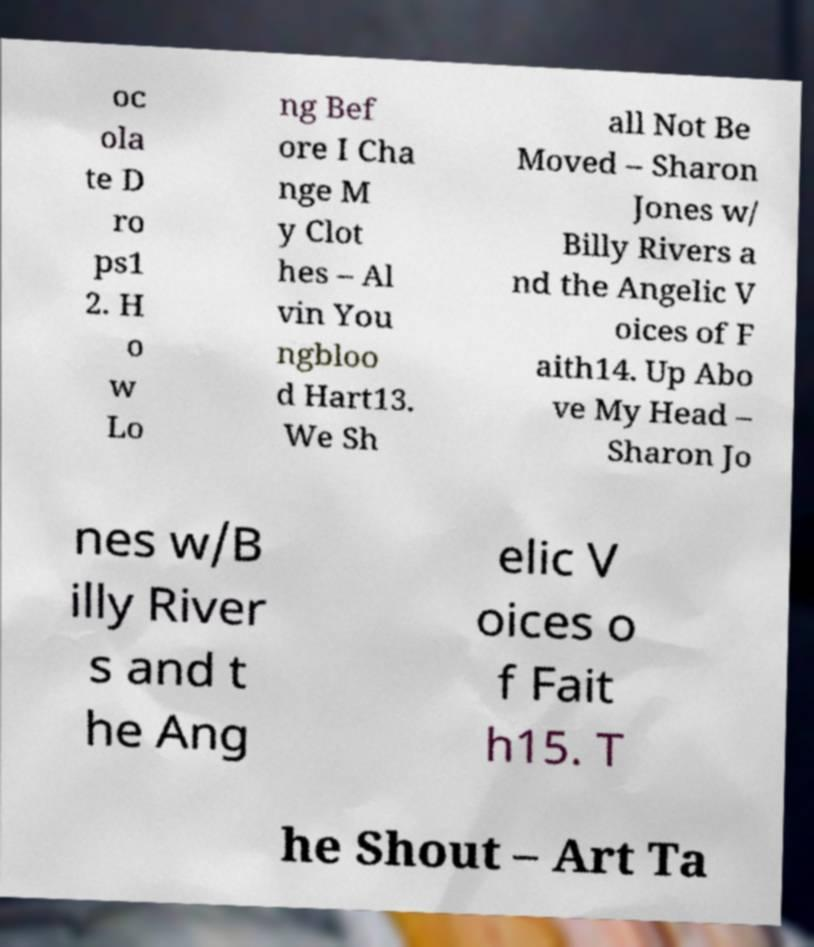Could you extract and type out the text from this image? oc ola te D ro ps1 2. H o w Lo ng Bef ore I Cha nge M y Clot hes – Al vin You ngbloo d Hart13. We Sh all Not Be Moved – Sharon Jones w/ Billy Rivers a nd the Angelic V oices of F aith14. Up Abo ve My Head – Sharon Jo nes w/B illy River s and t he Ang elic V oices o f Fait h15. T he Shout – Art Ta 